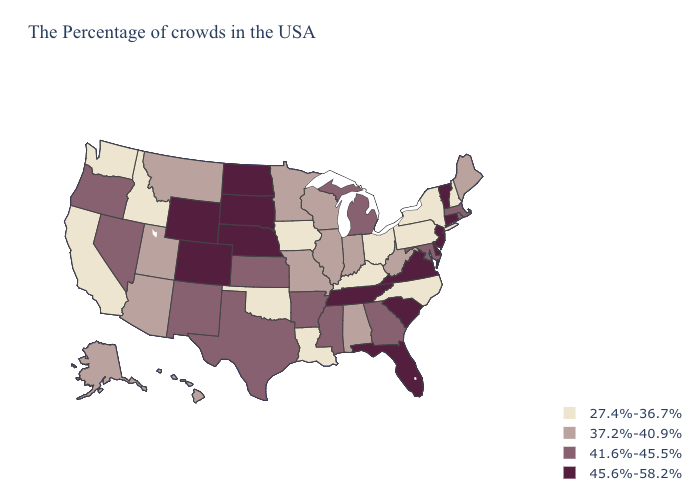What is the value of Kansas?
Keep it brief. 41.6%-45.5%. Does the first symbol in the legend represent the smallest category?
Short answer required. Yes. Name the states that have a value in the range 45.6%-58.2%?
Give a very brief answer. Vermont, Connecticut, New Jersey, Delaware, Virginia, South Carolina, Florida, Tennessee, Nebraska, South Dakota, North Dakota, Wyoming, Colorado. What is the highest value in states that border Colorado?
Be succinct. 45.6%-58.2%. Name the states that have a value in the range 45.6%-58.2%?
Answer briefly. Vermont, Connecticut, New Jersey, Delaware, Virginia, South Carolina, Florida, Tennessee, Nebraska, South Dakota, North Dakota, Wyoming, Colorado. What is the lowest value in states that border Colorado?
Short answer required. 27.4%-36.7%. What is the value of Arizona?
Short answer required. 37.2%-40.9%. Which states have the highest value in the USA?
Give a very brief answer. Vermont, Connecticut, New Jersey, Delaware, Virginia, South Carolina, Florida, Tennessee, Nebraska, South Dakota, North Dakota, Wyoming, Colorado. Which states have the highest value in the USA?
Keep it brief. Vermont, Connecticut, New Jersey, Delaware, Virginia, South Carolina, Florida, Tennessee, Nebraska, South Dakota, North Dakota, Wyoming, Colorado. What is the value of Kansas?
Concise answer only. 41.6%-45.5%. What is the highest value in the West ?
Quick response, please. 45.6%-58.2%. How many symbols are there in the legend?
Quick response, please. 4. Name the states that have a value in the range 37.2%-40.9%?
Short answer required. Maine, West Virginia, Indiana, Alabama, Wisconsin, Illinois, Missouri, Minnesota, Utah, Montana, Arizona, Alaska, Hawaii. What is the value of Georgia?
Keep it brief. 41.6%-45.5%. What is the value of Texas?
Quick response, please. 41.6%-45.5%. 